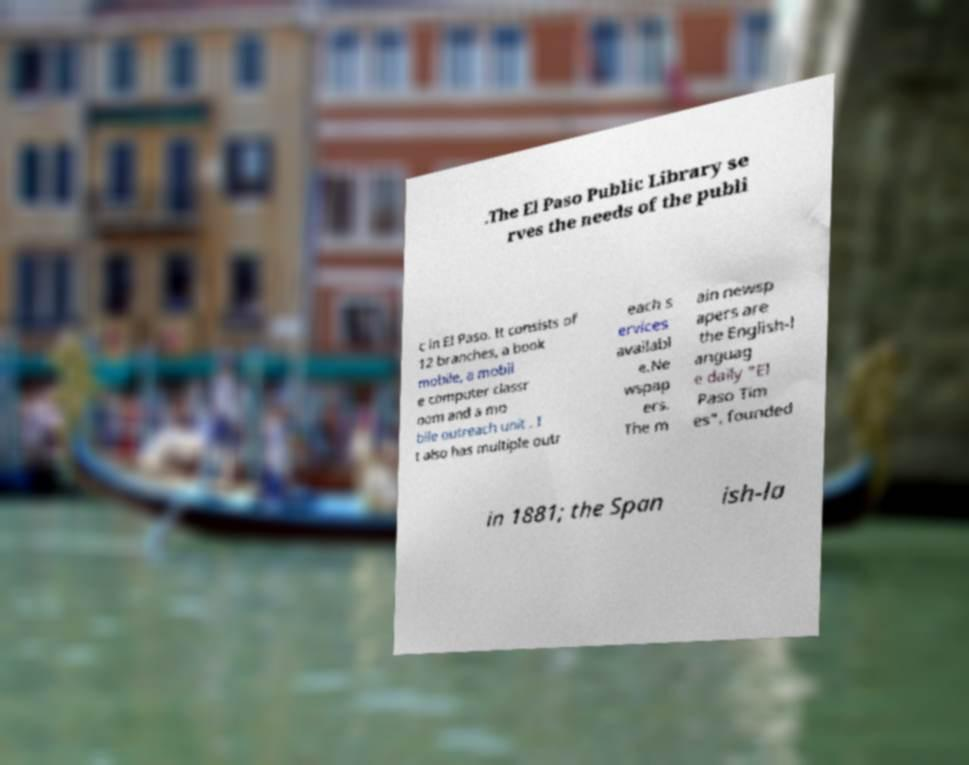Can you read and provide the text displayed in the image?This photo seems to have some interesting text. Can you extract and type it out for me? .The El Paso Public Library se rves the needs of the publi c in El Paso. It consists of 12 branches, a book mobile, a mobil e computer classr oom and a mo bile outreach unit . I t also has multiple outr each s ervices availabl e.Ne wspap ers. The m ain newsp apers are the English-l anguag e daily "El Paso Tim es", founded in 1881; the Span ish-la 